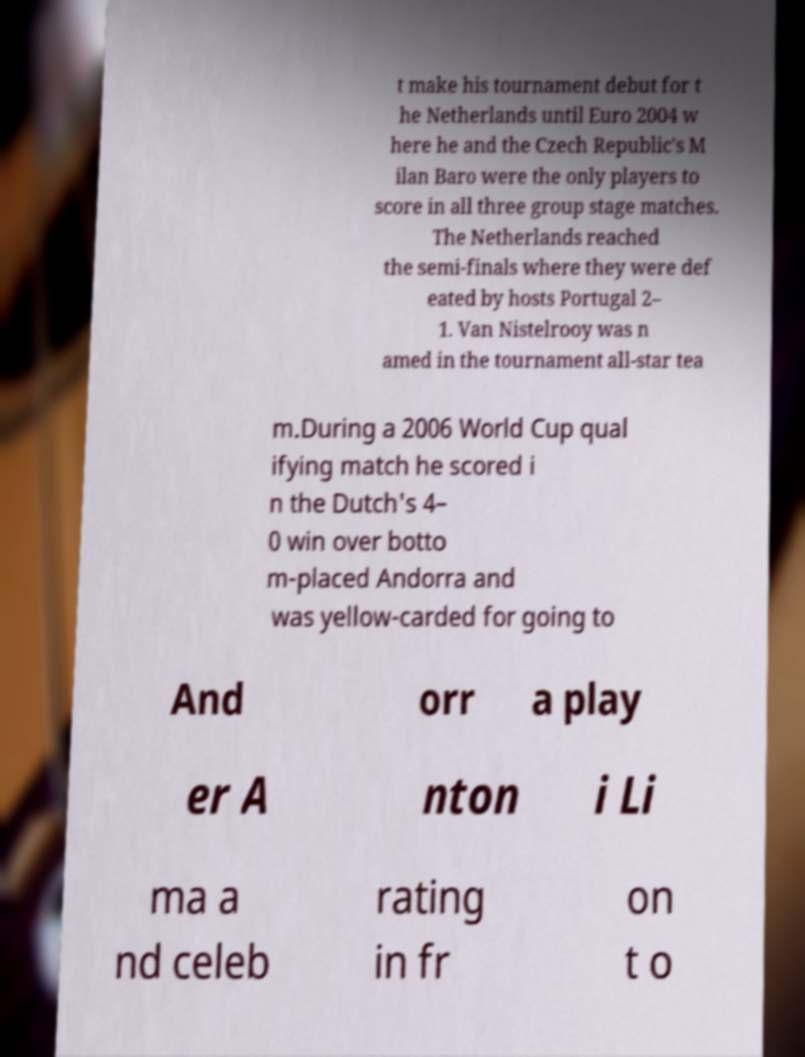Please identify and transcribe the text found in this image. t make his tournament debut for t he Netherlands until Euro 2004 w here he and the Czech Republic's M ilan Baro were the only players to score in all three group stage matches. The Netherlands reached the semi-finals where they were def eated by hosts Portugal 2– 1. Van Nistelrooy was n amed in the tournament all-star tea m.During a 2006 World Cup qual ifying match he scored i n the Dutch's 4– 0 win over botto m-placed Andorra and was yellow-carded for going to And orr a play er A nton i Li ma a nd celeb rating in fr on t o 